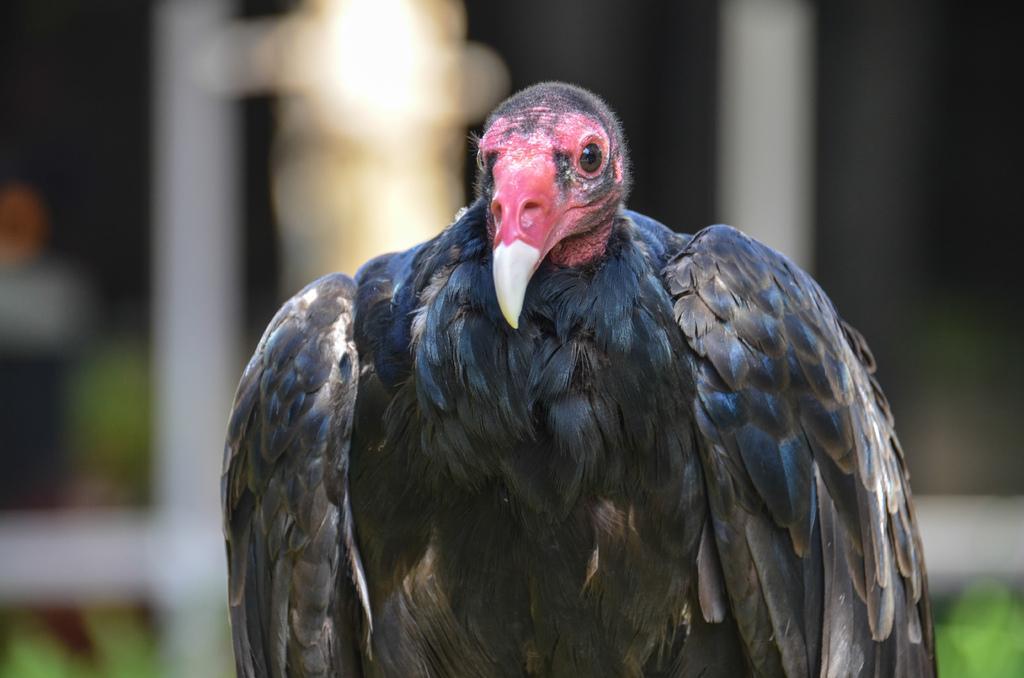Could you give a brief overview of what you see in this image? In this picture we can see a turkey vulture and behind the turkey there is a blurred background. 